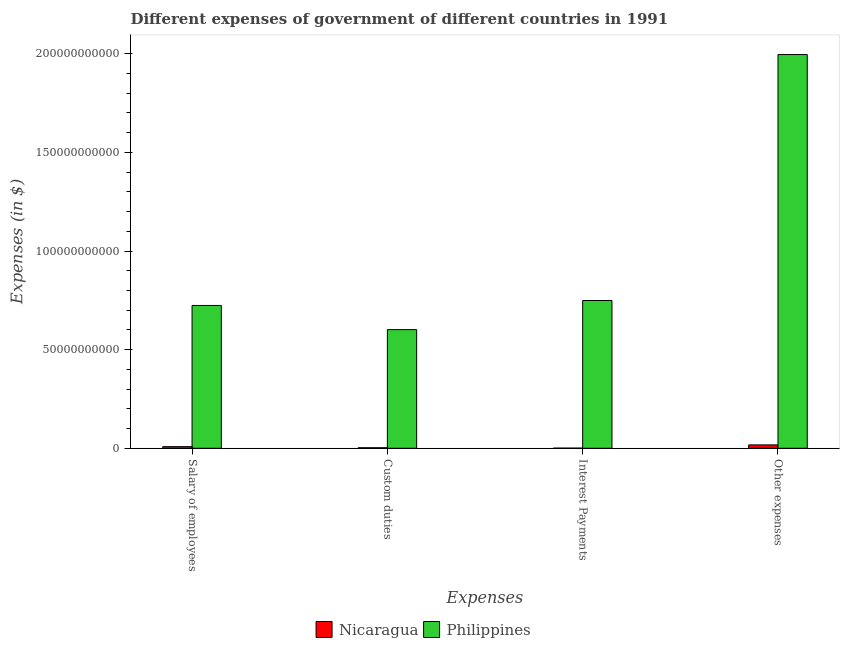How many different coloured bars are there?
Keep it short and to the point. 2. How many groups of bars are there?
Offer a terse response. 4. What is the label of the 3rd group of bars from the left?
Provide a succinct answer. Interest Payments. What is the amount spent on other expenses in Nicaragua?
Ensure brevity in your answer.  1.71e+09. Across all countries, what is the maximum amount spent on salary of employees?
Your answer should be very brief. 7.24e+1. Across all countries, what is the minimum amount spent on interest payments?
Provide a short and direct response. 8.48e+07. In which country was the amount spent on interest payments maximum?
Your response must be concise. Philippines. In which country was the amount spent on other expenses minimum?
Offer a terse response. Nicaragua. What is the total amount spent on salary of employees in the graph?
Offer a terse response. 7.32e+1. What is the difference between the amount spent on salary of employees in Nicaragua and that in Philippines?
Keep it short and to the point. -7.16e+1. What is the difference between the amount spent on custom duties in Philippines and the amount spent on salary of employees in Nicaragua?
Offer a terse response. 5.93e+1. What is the average amount spent on custom duties per country?
Give a very brief answer. 3.02e+1. What is the difference between the amount spent on salary of employees and amount spent on interest payments in Philippines?
Your answer should be compact. -2.52e+09. In how many countries, is the amount spent on interest payments greater than 60000000000 $?
Provide a short and direct response. 1. What is the ratio of the amount spent on custom duties in Philippines to that in Nicaragua?
Make the answer very short. 225.55. Is the amount spent on custom duties in Nicaragua less than that in Philippines?
Provide a short and direct response. Yes. Is the difference between the amount spent on salary of employees in Philippines and Nicaragua greater than the difference between the amount spent on interest payments in Philippines and Nicaragua?
Your response must be concise. No. What is the difference between the highest and the second highest amount spent on custom duties?
Your answer should be very brief. 5.99e+1. What is the difference between the highest and the lowest amount spent on salary of employees?
Offer a terse response. 7.16e+1. In how many countries, is the amount spent on custom duties greater than the average amount spent on custom duties taken over all countries?
Give a very brief answer. 1. What does the 2nd bar from the right in Custom duties represents?
Provide a short and direct response. Nicaragua. How many countries are there in the graph?
Your answer should be very brief. 2. Are the values on the major ticks of Y-axis written in scientific E-notation?
Ensure brevity in your answer.  No. How are the legend labels stacked?
Provide a succinct answer. Horizontal. What is the title of the graph?
Your answer should be compact. Different expenses of government of different countries in 1991. Does "India" appear as one of the legend labels in the graph?
Your answer should be compact. No. What is the label or title of the X-axis?
Provide a succinct answer. Expenses. What is the label or title of the Y-axis?
Give a very brief answer. Expenses (in $). What is the Expenses (in $) in Nicaragua in Salary of employees?
Offer a very short reply. 8.26e+08. What is the Expenses (in $) in Philippines in Salary of employees?
Ensure brevity in your answer.  7.24e+1. What is the Expenses (in $) in Nicaragua in Custom duties?
Make the answer very short. 2.67e+08. What is the Expenses (in $) of Philippines in Custom duties?
Ensure brevity in your answer.  6.02e+1. What is the Expenses (in $) in Nicaragua in Interest Payments?
Your response must be concise. 8.48e+07. What is the Expenses (in $) of Philippines in Interest Payments?
Keep it short and to the point. 7.49e+1. What is the Expenses (in $) in Nicaragua in Other expenses?
Your answer should be compact. 1.71e+09. What is the Expenses (in $) in Philippines in Other expenses?
Provide a short and direct response. 2.00e+11. Across all Expenses, what is the maximum Expenses (in $) of Nicaragua?
Make the answer very short. 1.71e+09. Across all Expenses, what is the maximum Expenses (in $) in Philippines?
Keep it short and to the point. 2.00e+11. Across all Expenses, what is the minimum Expenses (in $) of Nicaragua?
Your answer should be compact. 8.48e+07. Across all Expenses, what is the minimum Expenses (in $) of Philippines?
Offer a terse response. 6.02e+1. What is the total Expenses (in $) in Nicaragua in the graph?
Keep it short and to the point. 2.89e+09. What is the total Expenses (in $) of Philippines in the graph?
Make the answer very short. 4.07e+11. What is the difference between the Expenses (in $) of Nicaragua in Salary of employees and that in Custom duties?
Provide a short and direct response. 5.59e+08. What is the difference between the Expenses (in $) in Philippines in Salary of employees and that in Custom duties?
Give a very brief answer. 1.22e+1. What is the difference between the Expenses (in $) of Nicaragua in Salary of employees and that in Interest Payments?
Provide a succinct answer. 7.41e+08. What is the difference between the Expenses (in $) in Philippines in Salary of employees and that in Interest Payments?
Ensure brevity in your answer.  -2.52e+09. What is the difference between the Expenses (in $) in Nicaragua in Salary of employees and that in Other expenses?
Make the answer very short. -8.88e+08. What is the difference between the Expenses (in $) of Philippines in Salary of employees and that in Other expenses?
Ensure brevity in your answer.  -1.27e+11. What is the difference between the Expenses (in $) of Nicaragua in Custom duties and that in Interest Payments?
Provide a succinct answer. 1.82e+08. What is the difference between the Expenses (in $) in Philippines in Custom duties and that in Interest Payments?
Make the answer very short. -1.48e+1. What is the difference between the Expenses (in $) in Nicaragua in Custom duties and that in Other expenses?
Offer a terse response. -1.45e+09. What is the difference between the Expenses (in $) of Philippines in Custom duties and that in Other expenses?
Give a very brief answer. -1.39e+11. What is the difference between the Expenses (in $) in Nicaragua in Interest Payments and that in Other expenses?
Your answer should be compact. -1.63e+09. What is the difference between the Expenses (in $) of Philippines in Interest Payments and that in Other expenses?
Your response must be concise. -1.25e+11. What is the difference between the Expenses (in $) of Nicaragua in Salary of employees and the Expenses (in $) of Philippines in Custom duties?
Keep it short and to the point. -5.93e+1. What is the difference between the Expenses (in $) in Nicaragua in Salary of employees and the Expenses (in $) in Philippines in Interest Payments?
Your answer should be compact. -7.41e+1. What is the difference between the Expenses (in $) of Nicaragua in Salary of employees and the Expenses (in $) of Philippines in Other expenses?
Provide a short and direct response. -1.99e+11. What is the difference between the Expenses (in $) in Nicaragua in Custom duties and the Expenses (in $) in Philippines in Interest Payments?
Provide a succinct answer. -7.47e+1. What is the difference between the Expenses (in $) in Nicaragua in Custom duties and the Expenses (in $) in Philippines in Other expenses?
Provide a succinct answer. -1.99e+11. What is the difference between the Expenses (in $) in Nicaragua in Interest Payments and the Expenses (in $) in Philippines in Other expenses?
Your answer should be very brief. -2.00e+11. What is the average Expenses (in $) in Nicaragua per Expenses?
Your response must be concise. 7.23e+08. What is the average Expenses (in $) in Philippines per Expenses?
Make the answer very short. 1.02e+11. What is the difference between the Expenses (in $) in Nicaragua and Expenses (in $) in Philippines in Salary of employees?
Offer a terse response. -7.16e+1. What is the difference between the Expenses (in $) of Nicaragua and Expenses (in $) of Philippines in Custom duties?
Your response must be concise. -5.99e+1. What is the difference between the Expenses (in $) in Nicaragua and Expenses (in $) in Philippines in Interest Payments?
Your answer should be very brief. -7.48e+1. What is the difference between the Expenses (in $) of Nicaragua and Expenses (in $) of Philippines in Other expenses?
Your response must be concise. -1.98e+11. What is the ratio of the Expenses (in $) of Nicaragua in Salary of employees to that in Custom duties?
Your answer should be compact. 3.1. What is the ratio of the Expenses (in $) in Philippines in Salary of employees to that in Custom duties?
Keep it short and to the point. 1.2. What is the ratio of the Expenses (in $) in Nicaragua in Salary of employees to that in Interest Payments?
Your answer should be very brief. 9.74. What is the ratio of the Expenses (in $) in Philippines in Salary of employees to that in Interest Payments?
Your response must be concise. 0.97. What is the ratio of the Expenses (in $) of Nicaragua in Salary of employees to that in Other expenses?
Ensure brevity in your answer.  0.48. What is the ratio of the Expenses (in $) of Philippines in Salary of employees to that in Other expenses?
Offer a very short reply. 0.36. What is the ratio of the Expenses (in $) in Nicaragua in Custom duties to that in Interest Payments?
Your answer should be compact. 3.14. What is the ratio of the Expenses (in $) of Philippines in Custom duties to that in Interest Payments?
Offer a very short reply. 0.8. What is the ratio of the Expenses (in $) in Nicaragua in Custom duties to that in Other expenses?
Give a very brief answer. 0.16. What is the ratio of the Expenses (in $) in Philippines in Custom duties to that in Other expenses?
Provide a succinct answer. 0.3. What is the ratio of the Expenses (in $) of Nicaragua in Interest Payments to that in Other expenses?
Offer a very short reply. 0.05. What is the ratio of the Expenses (in $) in Philippines in Interest Payments to that in Other expenses?
Ensure brevity in your answer.  0.38. What is the difference between the highest and the second highest Expenses (in $) in Nicaragua?
Your answer should be compact. 8.88e+08. What is the difference between the highest and the second highest Expenses (in $) of Philippines?
Provide a succinct answer. 1.25e+11. What is the difference between the highest and the lowest Expenses (in $) of Nicaragua?
Offer a terse response. 1.63e+09. What is the difference between the highest and the lowest Expenses (in $) in Philippines?
Make the answer very short. 1.39e+11. 